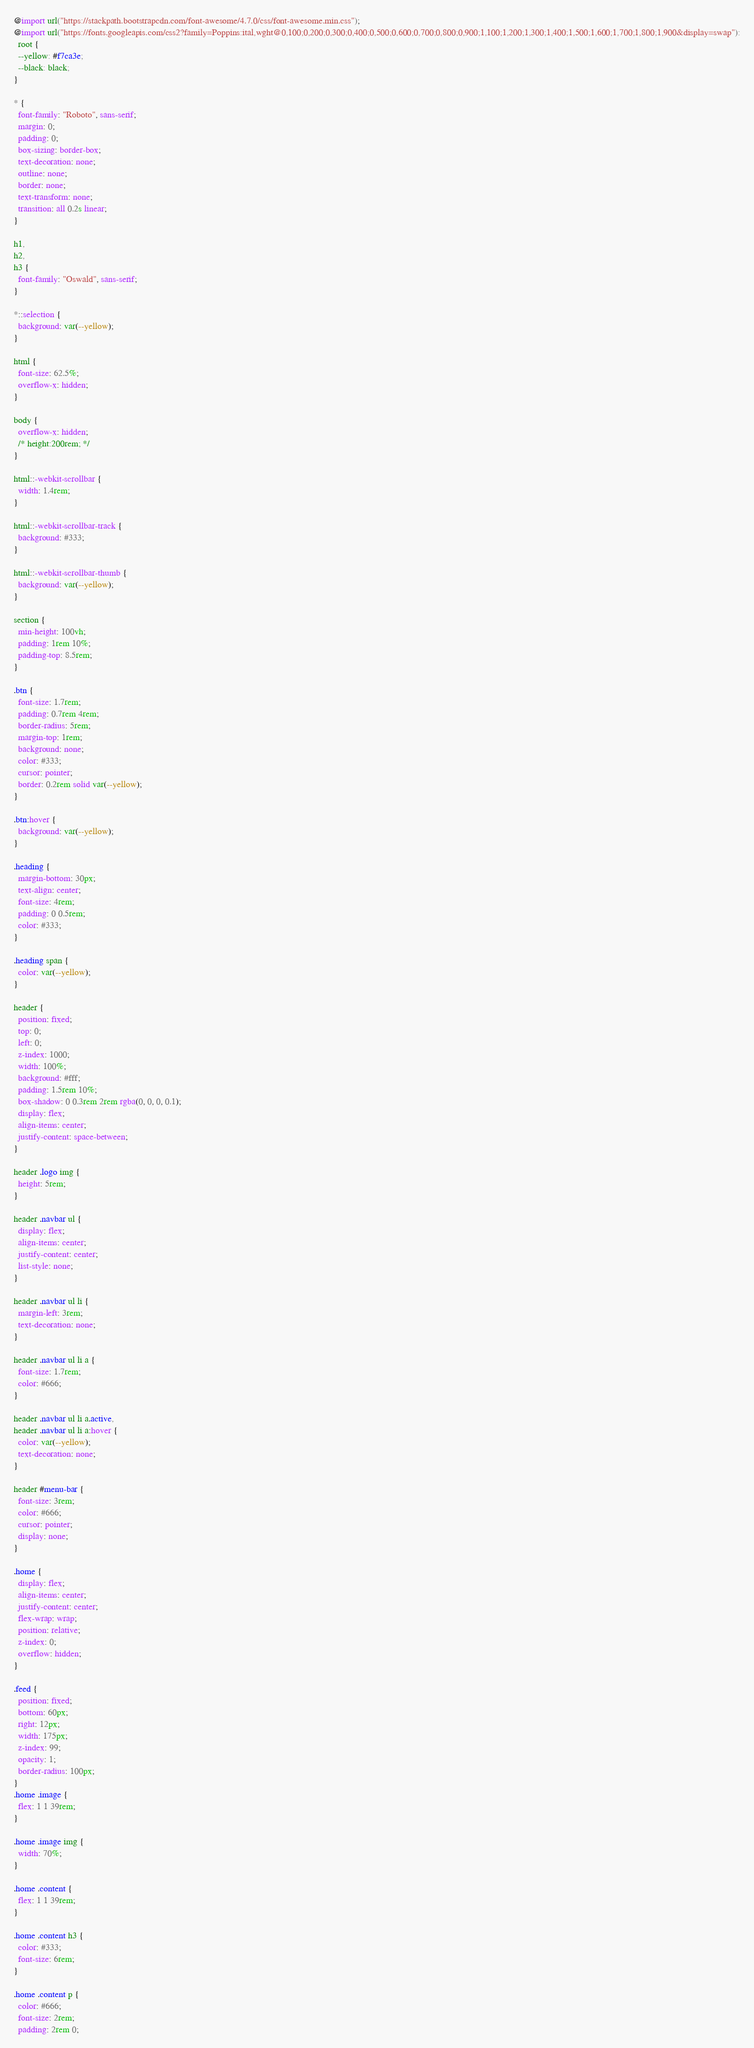Convert code to text. <code><loc_0><loc_0><loc_500><loc_500><_CSS_>@import url("https://stackpath.bootstrapcdn.com/font-awesome/4.7.0/css/font-awesome.min.css");
@import url("https://fonts.googleapis.com/css2?family=Poppins:ital,wght@0,100;0,200;0,300;0,400;0,500;0,600;0,700;0,800;0,900;1,100;1,200;1,300;1,400;1,500;1,600;1,700;1,800;1,900&display=swap"):
  root {
  --yellow: #f7ca3e;
  --black: black;
}

* {
  font-family: "Roboto", sans-serif;
  margin: 0;
  padding: 0;
  box-sizing: border-box;
  text-decoration: none;
  outline: none;
  border: none;
  text-transform: none;
  transition: all 0.2s linear;
}

h1,
h2,
h3 {
  font-family: "Oswald", sans-serif;
}

*::selection {
  background: var(--yellow);
}

html {
  font-size: 62.5%;
  overflow-x: hidden;
}

body {
  overflow-x: hidden;
  /* height:200rem; */
}

html::-webkit-scrollbar {
  width: 1.4rem;
}

html::-webkit-scrollbar-track {
  background: #333;
}

html::-webkit-scrollbar-thumb {
  background: var(--yellow);
}

section {
  min-height: 100vh;
  padding: 1rem 10%;
  padding-top: 8.5rem;
}

.btn {
  font-size: 1.7rem;
  padding: 0.7rem 4rem;
  border-radius: 5rem;
  margin-top: 1rem;
  background: none;
  color: #333;
  cursor: pointer;
  border: 0.2rem solid var(--yellow);
}

.btn:hover {
  background: var(--yellow);
}

.heading {
  margin-bottom: 30px;
  text-align: center;
  font-size: 4rem;
  padding: 0 0.5rem;
  color: #333;
}

.heading span {
  color: var(--yellow);
}

header {
  position: fixed;
  top: 0;
  left: 0;
  z-index: 1000;
  width: 100%;
  background: #fff;
  padding: 1.5rem 10%;
  box-shadow: 0 0.3rem 2rem rgba(0, 0, 0, 0.1);
  display: flex;
  align-items: center;
  justify-content: space-between;
}

header .logo img {
  height: 5rem;
}

header .navbar ul {
  display: flex;
  align-items: center;
  justify-content: center;
  list-style: none;
}

header .navbar ul li {
  margin-left: 3rem;
  text-decoration: none;
}

header .navbar ul li a {
  font-size: 1.7rem;
  color: #666;
}

header .navbar ul li a.active,
header .navbar ul li a:hover {
  color: var(--yellow);
  text-decoration: none;
}

header #menu-bar {
  font-size: 3rem;
  color: #666;
  cursor: pointer;
  display: none;
}

.home {
  display: flex;
  align-items: center;
  justify-content: center;
  flex-wrap: wrap;
  position: relative;
  z-index: 0;
  overflow: hidden;
}

.feed {
  position: fixed;
  bottom: 60px;
  right: 12px;
  width: 175px;
  z-index: 99;
  opacity: 1;
  border-radius: 100px;
}
.home .image {
  flex: 1 1 39rem;
}

.home .image img {
  width: 70%;
}

.home .content {
  flex: 1 1 39rem;
}

.home .content h3 {
  color: #333;
  font-size: 6rem;
}

.home .content p {
  color: #666;
  font-size: 2rem;
  padding: 2rem 0;</code> 